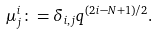<formula> <loc_0><loc_0><loc_500><loc_500>\mu ^ { i } _ { j } \colon = \delta _ { i , j } q ^ { ( 2 i - N + 1 ) / 2 } .</formula> 